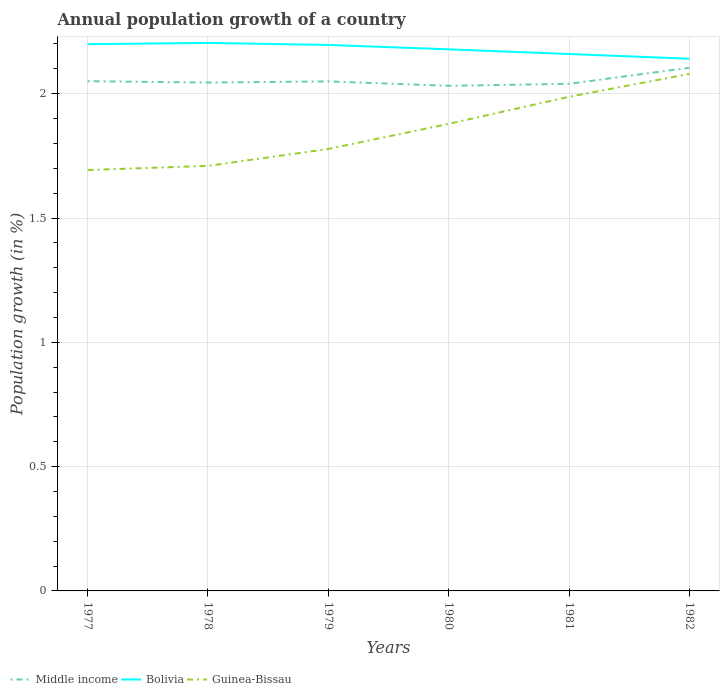How many different coloured lines are there?
Make the answer very short. 3. Is the number of lines equal to the number of legend labels?
Offer a very short reply. Yes. Across all years, what is the maximum annual population growth in Bolivia?
Give a very brief answer. 2.14. What is the total annual population growth in Guinea-Bissau in the graph?
Ensure brevity in your answer.  -0.17. What is the difference between the highest and the second highest annual population growth in Guinea-Bissau?
Give a very brief answer. 0.39. What is the difference between the highest and the lowest annual population growth in Middle income?
Your answer should be compact. 1. What is the difference between two consecutive major ticks on the Y-axis?
Provide a short and direct response. 0.5. Are the values on the major ticks of Y-axis written in scientific E-notation?
Provide a short and direct response. No. Does the graph contain grids?
Your answer should be very brief. Yes. How many legend labels are there?
Provide a short and direct response. 3. What is the title of the graph?
Keep it short and to the point. Annual population growth of a country. Does "Estonia" appear as one of the legend labels in the graph?
Your response must be concise. No. What is the label or title of the Y-axis?
Make the answer very short. Population growth (in %). What is the Population growth (in %) in Middle income in 1977?
Your response must be concise. 2.05. What is the Population growth (in %) of Bolivia in 1977?
Your response must be concise. 2.2. What is the Population growth (in %) of Guinea-Bissau in 1977?
Make the answer very short. 1.69. What is the Population growth (in %) in Middle income in 1978?
Make the answer very short. 2.04. What is the Population growth (in %) of Bolivia in 1978?
Ensure brevity in your answer.  2.2. What is the Population growth (in %) of Guinea-Bissau in 1978?
Ensure brevity in your answer.  1.71. What is the Population growth (in %) in Middle income in 1979?
Your answer should be compact. 2.05. What is the Population growth (in %) of Bolivia in 1979?
Provide a short and direct response. 2.2. What is the Population growth (in %) in Guinea-Bissau in 1979?
Your answer should be very brief. 1.78. What is the Population growth (in %) in Middle income in 1980?
Your answer should be very brief. 2.03. What is the Population growth (in %) of Bolivia in 1980?
Offer a terse response. 2.18. What is the Population growth (in %) in Guinea-Bissau in 1980?
Your response must be concise. 1.88. What is the Population growth (in %) of Middle income in 1981?
Offer a terse response. 2.04. What is the Population growth (in %) in Bolivia in 1981?
Ensure brevity in your answer.  2.16. What is the Population growth (in %) in Guinea-Bissau in 1981?
Provide a short and direct response. 1.99. What is the Population growth (in %) in Middle income in 1982?
Your answer should be very brief. 2.1. What is the Population growth (in %) in Bolivia in 1982?
Provide a short and direct response. 2.14. What is the Population growth (in %) in Guinea-Bissau in 1982?
Keep it short and to the point. 2.08. Across all years, what is the maximum Population growth (in %) of Middle income?
Give a very brief answer. 2.1. Across all years, what is the maximum Population growth (in %) of Bolivia?
Provide a succinct answer. 2.2. Across all years, what is the maximum Population growth (in %) in Guinea-Bissau?
Make the answer very short. 2.08. Across all years, what is the minimum Population growth (in %) in Middle income?
Ensure brevity in your answer.  2.03. Across all years, what is the minimum Population growth (in %) of Bolivia?
Provide a succinct answer. 2.14. Across all years, what is the minimum Population growth (in %) of Guinea-Bissau?
Offer a very short reply. 1.69. What is the total Population growth (in %) in Middle income in the graph?
Your answer should be very brief. 12.32. What is the total Population growth (in %) in Bolivia in the graph?
Your answer should be compact. 13.08. What is the total Population growth (in %) in Guinea-Bissau in the graph?
Offer a very short reply. 11.13. What is the difference between the Population growth (in %) of Middle income in 1977 and that in 1978?
Offer a terse response. 0.01. What is the difference between the Population growth (in %) in Bolivia in 1977 and that in 1978?
Give a very brief answer. -0.01. What is the difference between the Population growth (in %) of Guinea-Bissau in 1977 and that in 1978?
Your answer should be compact. -0.02. What is the difference between the Population growth (in %) in Middle income in 1977 and that in 1979?
Provide a short and direct response. 0. What is the difference between the Population growth (in %) of Bolivia in 1977 and that in 1979?
Make the answer very short. 0. What is the difference between the Population growth (in %) in Guinea-Bissau in 1977 and that in 1979?
Provide a succinct answer. -0.08. What is the difference between the Population growth (in %) of Middle income in 1977 and that in 1980?
Ensure brevity in your answer.  0.02. What is the difference between the Population growth (in %) in Bolivia in 1977 and that in 1980?
Keep it short and to the point. 0.02. What is the difference between the Population growth (in %) of Guinea-Bissau in 1977 and that in 1980?
Provide a short and direct response. -0.19. What is the difference between the Population growth (in %) of Middle income in 1977 and that in 1981?
Your answer should be compact. 0.01. What is the difference between the Population growth (in %) in Bolivia in 1977 and that in 1981?
Make the answer very short. 0.04. What is the difference between the Population growth (in %) of Guinea-Bissau in 1977 and that in 1981?
Keep it short and to the point. -0.29. What is the difference between the Population growth (in %) of Middle income in 1977 and that in 1982?
Ensure brevity in your answer.  -0.05. What is the difference between the Population growth (in %) of Bolivia in 1977 and that in 1982?
Provide a succinct answer. 0.06. What is the difference between the Population growth (in %) in Guinea-Bissau in 1977 and that in 1982?
Ensure brevity in your answer.  -0.39. What is the difference between the Population growth (in %) of Middle income in 1978 and that in 1979?
Make the answer very short. -0. What is the difference between the Population growth (in %) of Bolivia in 1978 and that in 1979?
Provide a short and direct response. 0.01. What is the difference between the Population growth (in %) of Guinea-Bissau in 1978 and that in 1979?
Your response must be concise. -0.07. What is the difference between the Population growth (in %) of Middle income in 1978 and that in 1980?
Your response must be concise. 0.01. What is the difference between the Population growth (in %) in Bolivia in 1978 and that in 1980?
Your response must be concise. 0.03. What is the difference between the Population growth (in %) of Guinea-Bissau in 1978 and that in 1980?
Offer a terse response. -0.17. What is the difference between the Population growth (in %) of Middle income in 1978 and that in 1981?
Your answer should be very brief. 0.01. What is the difference between the Population growth (in %) in Bolivia in 1978 and that in 1981?
Offer a terse response. 0.04. What is the difference between the Population growth (in %) in Guinea-Bissau in 1978 and that in 1981?
Offer a terse response. -0.28. What is the difference between the Population growth (in %) in Middle income in 1978 and that in 1982?
Your answer should be very brief. -0.06. What is the difference between the Population growth (in %) of Bolivia in 1978 and that in 1982?
Ensure brevity in your answer.  0.06. What is the difference between the Population growth (in %) in Guinea-Bissau in 1978 and that in 1982?
Provide a short and direct response. -0.37. What is the difference between the Population growth (in %) of Middle income in 1979 and that in 1980?
Ensure brevity in your answer.  0.02. What is the difference between the Population growth (in %) in Bolivia in 1979 and that in 1980?
Give a very brief answer. 0.02. What is the difference between the Population growth (in %) of Guinea-Bissau in 1979 and that in 1980?
Ensure brevity in your answer.  -0.1. What is the difference between the Population growth (in %) of Middle income in 1979 and that in 1981?
Provide a succinct answer. 0.01. What is the difference between the Population growth (in %) of Bolivia in 1979 and that in 1981?
Ensure brevity in your answer.  0.04. What is the difference between the Population growth (in %) in Guinea-Bissau in 1979 and that in 1981?
Offer a terse response. -0.21. What is the difference between the Population growth (in %) of Middle income in 1979 and that in 1982?
Offer a very short reply. -0.05. What is the difference between the Population growth (in %) in Bolivia in 1979 and that in 1982?
Ensure brevity in your answer.  0.06. What is the difference between the Population growth (in %) of Guinea-Bissau in 1979 and that in 1982?
Offer a terse response. -0.3. What is the difference between the Population growth (in %) in Middle income in 1980 and that in 1981?
Your answer should be compact. -0.01. What is the difference between the Population growth (in %) of Bolivia in 1980 and that in 1981?
Your answer should be compact. 0.02. What is the difference between the Population growth (in %) of Guinea-Bissau in 1980 and that in 1981?
Offer a terse response. -0.11. What is the difference between the Population growth (in %) of Middle income in 1980 and that in 1982?
Keep it short and to the point. -0.07. What is the difference between the Population growth (in %) of Bolivia in 1980 and that in 1982?
Offer a very short reply. 0.04. What is the difference between the Population growth (in %) in Guinea-Bissau in 1980 and that in 1982?
Offer a terse response. -0.2. What is the difference between the Population growth (in %) of Middle income in 1981 and that in 1982?
Make the answer very short. -0.06. What is the difference between the Population growth (in %) in Bolivia in 1981 and that in 1982?
Keep it short and to the point. 0.02. What is the difference between the Population growth (in %) of Guinea-Bissau in 1981 and that in 1982?
Give a very brief answer. -0.09. What is the difference between the Population growth (in %) in Middle income in 1977 and the Population growth (in %) in Bolivia in 1978?
Give a very brief answer. -0.15. What is the difference between the Population growth (in %) in Middle income in 1977 and the Population growth (in %) in Guinea-Bissau in 1978?
Make the answer very short. 0.34. What is the difference between the Population growth (in %) in Bolivia in 1977 and the Population growth (in %) in Guinea-Bissau in 1978?
Provide a succinct answer. 0.49. What is the difference between the Population growth (in %) in Middle income in 1977 and the Population growth (in %) in Bolivia in 1979?
Your response must be concise. -0.15. What is the difference between the Population growth (in %) in Middle income in 1977 and the Population growth (in %) in Guinea-Bissau in 1979?
Make the answer very short. 0.27. What is the difference between the Population growth (in %) of Bolivia in 1977 and the Population growth (in %) of Guinea-Bissau in 1979?
Make the answer very short. 0.42. What is the difference between the Population growth (in %) of Middle income in 1977 and the Population growth (in %) of Bolivia in 1980?
Give a very brief answer. -0.13. What is the difference between the Population growth (in %) of Middle income in 1977 and the Population growth (in %) of Guinea-Bissau in 1980?
Ensure brevity in your answer.  0.17. What is the difference between the Population growth (in %) of Bolivia in 1977 and the Population growth (in %) of Guinea-Bissau in 1980?
Your response must be concise. 0.32. What is the difference between the Population growth (in %) of Middle income in 1977 and the Population growth (in %) of Bolivia in 1981?
Make the answer very short. -0.11. What is the difference between the Population growth (in %) in Middle income in 1977 and the Population growth (in %) in Guinea-Bissau in 1981?
Your response must be concise. 0.06. What is the difference between the Population growth (in %) of Bolivia in 1977 and the Population growth (in %) of Guinea-Bissau in 1981?
Offer a terse response. 0.21. What is the difference between the Population growth (in %) in Middle income in 1977 and the Population growth (in %) in Bolivia in 1982?
Give a very brief answer. -0.09. What is the difference between the Population growth (in %) of Middle income in 1977 and the Population growth (in %) of Guinea-Bissau in 1982?
Your answer should be compact. -0.03. What is the difference between the Population growth (in %) in Bolivia in 1977 and the Population growth (in %) in Guinea-Bissau in 1982?
Keep it short and to the point. 0.12. What is the difference between the Population growth (in %) of Middle income in 1978 and the Population growth (in %) of Bolivia in 1979?
Offer a terse response. -0.15. What is the difference between the Population growth (in %) of Middle income in 1978 and the Population growth (in %) of Guinea-Bissau in 1979?
Your answer should be compact. 0.27. What is the difference between the Population growth (in %) in Bolivia in 1978 and the Population growth (in %) in Guinea-Bissau in 1979?
Provide a short and direct response. 0.43. What is the difference between the Population growth (in %) in Middle income in 1978 and the Population growth (in %) in Bolivia in 1980?
Your answer should be compact. -0.13. What is the difference between the Population growth (in %) of Middle income in 1978 and the Population growth (in %) of Guinea-Bissau in 1980?
Offer a very short reply. 0.17. What is the difference between the Population growth (in %) in Bolivia in 1978 and the Population growth (in %) in Guinea-Bissau in 1980?
Your answer should be very brief. 0.33. What is the difference between the Population growth (in %) of Middle income in 1978 and the Population growth (in %) of Bolivia in 1981?
Make the answer very short. -0.11. What is the difference between the Population growth (in %) of Middle income in 1978 and the Population growth (in %) of Guinea-Bissau in 1981?
Offer a very short reply. 0.06. What is the difference between the Population growth (in %) in Bolivia in 1978 and the Population growth (in %) in Guinea-Bissau in 1981?
Your answer should be very brief. 0.22. What is the difference between the Population growth (in %) of Middle income in 1978 and the Population growth (in %) of Bolivia in 1982?
Your answer should be compact. -0.1. What is the difference between the Population growth (in %) of Middle income in 1978 and the Population growth (in %) of Guinea-Bissau in 1982?
Make the answer very short. -0.03. What is the difference between the Population growth (in %) in Bolivia in 1978 and the Population growth (in %) in Guinea-Bissau in 1982?
Your response must be concise. 0.12. What is the difference between the Population growth (in %) in Middle income in 1979 and the Population growth (in %) in Bolivia in 1980?
Offer a very short reply. -0.13. What is the difference between the Population growth (in %) in Middle income in 1979 and the Population growth (in %) in Guinea-Bissau in 1980?
Make the answer very short. 0.17. What is the difference between the Population growth (in %) of Bolivia in 1979 and the Population growth (in %) of Guinea-Bissau in 1980?
Offer a very short reply. 0.32. What is the difference between the Population growth (in %) of Middle income in 1979 and the Population growth (in %) of Bolivia in 1981?
Give a very brief answer. -0.11. What is the difference between the Population growth (in %) in Middle income in 1979 and the Population growth (in %) in Guinea-Bissau in 1981?
Your response must be concise. 0.06. What is the difference between the Population growth (in %) of Bolivia in 1979 and the Population growth (in %) of Guinea-Bissau in 1981?
Your response must be concise. 0.21. What is the difference between the Population growth (in %) of Middle income in 1979 and the Population growth (in %) of Bolivia in 1982?
Provide a succinct answer. -0.09. What is the difference between the Population growth (in %) in Middle income in 1979 and the Population growth (in %) in Guinea-Bissau in 1982?
Your answer should be compact. -0.03. What is the difference between the Population growth (in %) in Bolivia in 1979 and the Population growth (in %) in Guinea-Bissau in 1982?
Provide a succinct answer. 0.12. What is the difference between the Population growth (in %) of Middle income in 1980 and the Population growth (in %) of Bolivia in 1981?
Your answer should be compact. -0.13. What is the difference between the Population growth (in %) of Middle income in 1980 and the Population growth (in %) of Guinea-Bissau in 1981?
Give a very brief answer. 0.04. What is the difference between the Population growth (in %) of Bolivia in 1980 and the Population growth (in %) of Guinea-Bissau in 1981?
Offer a very short reply. 0.19. What is the difference between the Population growth (in %) of Middle income in 1980 and the Population growth (in %) of Bolivia in 1982?
Your response must be concise. -0.11. What is the difference between the Population growth (in %) in Middle income in 1980 and the Population growth (in %) in Guinea-Bissau in 1982?
Offer a very short reply. -0.05. What is the difference between the Population growth (in %) in Bolivia in 1980 and the Population growth (in %) in Guinea-Bissau in 1982?
Give a very brief answer. 0.1. What is the difference between the Population growth (in %) of Middle income in 1981 and the Population growth (in %) of Bolivia in 1982?
Your response must be concise. -0.1. What is the difference between the Population growth (in %) in Middle income in 1981 and the Population growth (in %) in Guinea-Bissau in 1982?
Your answer should be compact. -0.04. What is the difference between the Population growth (in %) of Bolivia in 1981 and the Population growth (in %) of Guinea-Bissau in 1982?
Keep it short and to the point. 0.08. What is the average Population growth (in %) of Middle income per year?
Keep it short and to the point. 2.05. What is the average Population growth (in %) of Bolivia per year?
Give a very brief answer. 2.18. What is the average Population growth (in %) of Guinea-Bissau per year?
Offer a terse response. 1.85. In the year 1977, what is the difference between the Population growth (in %) of Middle income and Population growth (in %) of Bolivia?
Provide a succinct answer. -0.15. In the year 1977, what is the difference between the Population growth (in %) in Middle income and Population growth (in %) in Guinea-Bissau?
Keep it short and to the point. 0.36. In the year 1977, what is the difference between the Population growth (in %) of Bolivia and Population growth (in %) of Guinea-Bissau?
Give a very brief answer. 0.51. In the year 1978, what is the difference between the Population growth (in %) in Middle income and Population growth (in %) in Bolivia?
Offer a terse response. -0.16. In the year 1978, what is the difference between the Population growth (in %) in Middle income and Population growth (in %) in Guinea-Bissau?
Offer a terse response. 0.34. In the year 1978, what is the difference between the Population growth (in %) of Bolivia and Population growth (in %) of Guinea-Bissau?
Provide a short and direct response. 0.49. In the year 1979, what is the difference between the Population growth (in %) in Middle income and Population growth (in %) in Bolivia?
Your response must be concise. -0.15. In the year 1979, what is the difference between the Population growth (in %) in Middle income and Population growth (in %) in Guinea-Bissau?
Offer a terse response. 0.27. In the year 1979, what is the difference between the Population growth (in %) of Bolivia and Population growth (in %) of Guinea-Bissau?
Provide a short and direct response. 0.42. In the year 1980, what is the difference between the Population growth (in %) of Middle income and Population growth (in %) of Bolivia?
Offer a very short reply. -0.15. In the year 1980, what is the difference between the Population growth (in %) in Middle income and Population growth (in %) in Guinea-Bissau?
Make the answer very short. 0.15. In the year 1980, what is the difference between the Population growth (in %) in Bolivia and Population growth (in %) in Guinea-Bissau?
Provide a succinct answer. 0.3. In the year 1981, what is the difference between the Population growth (in %) of Middle income and Population growth (in %) of Bolivia?
Provide a short and direct response. -0.12. In the year 1981, what is the difference between the Population growth (in %) of Middle income and Population growth (in %) of Guinea-Bissau?
Offer a terse response. 0.05. In the year 1981, what is the difference between the Population growth (in %) in Bolivia and Population growth (in %) in Guinea-Bissau?
Offer a very short reply. 0.17. In the year 1982, what is the difference between the Population growth (in %) in Middle income and Population growth (in %) in Bolivia?
Make the answer very short. -0.04. In the year 1982, what is the difference between the Population growth (in %) of Middle income and Population growth (in %) of Guinea-Bissau?
Offer a terse response. 0.02. In the year 1982, what is the difference between the Population growth (in %) in Bolivia and Population growth (in %) in Guinea-Bissau?
Ensure brevity in your answer.  0.06. What is the ratio of the Population growth (in %) of Guinea-Bissau in 1977 to that in 1978?
Give a very brief answer. 0.99. What is the ratio of the Population growth (in %) of Bolivia in 1977 to that in 1979?
Offer a very short reply. 1. What is the ratio of the Population growth (in %) in Guinea-Bissau in 1977 to that in 1979?
Provide a short and direct response. 0.95. What is the ratio of the Population growth (in %) in Middle income in 1977 to that in 1980?
Provide a short and direct response. 1.01. What is the ratio of the Population growth (in %) in Bolivia in 1977 to that in 1980?
Your answer should be compact. 1.01. What is the ratio of the Population growth (in %) in Guinea-Bissau in 1977 to that in 1980?
Your answer should be very brief. 0.9. What is the ratio of the Population growth (in %) in Middle income in 1977 to that in 1981?
Your response must be concise. 1.01. What is the ratio of the Population growth (in %) in Bolivia in 1977 to that in 1981?
Keep it short and to the point. 1.02. What is the ratio of the Population growth (in %) in Guinea-Bissau in 1977 to that in 1981?
Provide a short and direct response. 0.85. What is the ratio of the Population growth (in %) in Middle income in 1977 to that in 1982?
Provide a succinct answer. 0.97. What is the ratio of the Population growth (in %) in Bolivia in 1977 to that in 1982?
Make the answer very short. 1.03. What is the ratio of the Population growth (in %) of Guinea-Bissau in 1977 to that in 1982?
Your answer should be compact. 0.81. What is the ratio of the Population growth (in %) of Middle income in 1978 to that in 1979?
Keep it short and to the point. 1. What is the ratio of the Population growth (in %) of Bolivia in 1978 to that in 1979?
Your answer should be very brief. 1. What is the ratio of the Population growth (in %) of Guinea-Bissau in 1978 to that in 1979?
Keep it short and to the point. 0.96. What is the ratio of the Population growth (in %) of Bolivia in 1978 to that in 1980?
Your response must be concise. 1.01. What is the ratio of the Population growth (in %) of Guinea-Bissau in 1978 to that in 1980?
Give a very brief answer. 0.91. What is the ratio of the Population growth (in %) of Bolivia in 1978 to that in 1981?
Your answer should be very brief. 1.02. What is the ratio of the Population growth (in %) of Guinea-Bissau in 1978 to that in 1981?
Provide a short and direct response. 0.86. What is the ratio of the Population growth (in %) in Middle income in 1978 to that in 1982?
Your answer should be compact. 0.97. What is the ratio of the Population growth (in %) in Bolivia in 1978 to that in 1982?
Make the answer very short. 1.03. What is the ratio of the Population growth (in %) in Guinea-Bissau in 1978 to that in 1982?
Provide a short and direct response. 0.82. What is the ratio of the Population growth (in %) in Middle income in 1979 to that in 1980?
Offer a terse response. 1.01. What is the ratio of the Population growth (in %) in Bolivia in 1979 to that in 1980?
Provide a succinct answer. 1.01. What is the ratio of the Population growth (in %) of Guinea-Bissau in 1979 to that in 1980?
Make the answer very short. 0.95. What is the ratio of the Population growth (in %) of Bolivia in 1979 to that in 1981?
Make the answer very short. 1.02. What is the ratio of the Population growth (in %) in Guinea-Bissau in 1979 to that in 1981?
Make the answer very short. 0.89. What is the ratio of the Population growth (in %) of Middle income in 1979 to that in 1982?
Your answer should be compact. 0.97. What is the ratio of the Population growth (in %) in Bolivia in 1979 to that in 1982?
Offer a very short reply. 1.03. What is the ratio of the Population growth (in %) in Guinea-Bissau in 1979 to that in 1982?
Offer a terse response. 0.85. What is the ratio of the Population growth (in %) in Bolivia in 1980 to that in 1981?
Provide a succinct answer. 1.01. What is the ratio of the Population growth (in %) in Guinea-Bissau in 1980 to that in 1981?
Your response must be concise. 0.95. What is the ratio of the Population growth (in %) in Middle income in 1980 to that in 1982?
Give a very brief answer. 0.97. What is the ratio of the Population growth (in %) in Bolivia in 1980 to that in 1982?
Make the answer very short. 1.02. What is the ratio of the Population growth (in %) of Guinea-Bissau in 1980 to that in 1982?
Give a very brief answer. 0.9. What is the ratio of the Population growth (in %) in Middle income in 1981 to that in 1982?
Provide a succinct answer. 0.97. What is the ratio of the Population growth (in %) in Bolivia in 1981 to that in 1982?
Your response must be concise. 1.01. What is the ratio of the Population growth (in %) of Guinea-Bissau in 1981 to that in 1982?
Your answer should be very brief. 0.96. What is the difference between the highest and the second highest Population growth (in %) of Middle income?
Your response must be concise. 0.05. What is the difference between the highest and the second highest Population growth (in %) in Bolivia?
Offer a terse response. 0.01. What is the difference between the highest and the second highest Population growth (in %) of Guinea-Bissau?
Keep it short and to the point. 0.09. What is the difference between the highest and the lowest Population growth (in %) in Middle income?
Offer a terse response. 0.07. What is the difference between the highest and the lowest Population growth (in %) of Bolivia?
Provide a short and direct response. 0.06. What is the difference between the highest and the lowest Population growth (in %) of Guinea-Bissau?
Provide a succinct answer. 0.39. 